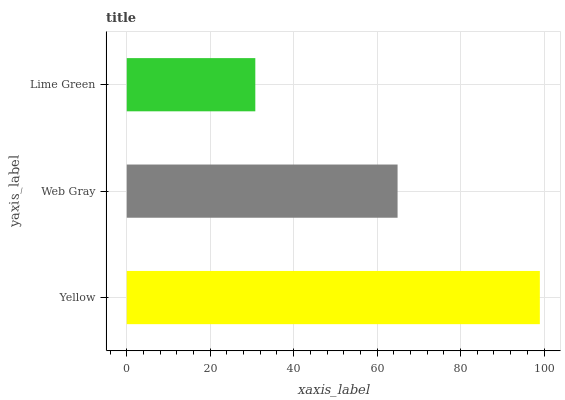Is Lime Green the minimum?
Answer yes or no. Yes. Is Yellow the maximum?
Answer yes or no. Yes. Is Web Gray the minimum?
Answer yes or no. No. Is Web Gray the maximum?
Answer yes or no. No. Is Yellow greater than Web Gray?
Answer yes or no. Yes. Is Web Gray less than Yellow?
Answer yes or no. Yes. Is Web Gray greater than Yellow?
Answer yes or no. No. Is Yellow less than Web Gray?
Answer yes or no. No. Is Web Gray the high median?
Answer yes or no. Yes. Is Web Gray the low median?
Answer yes or no. Yes. Is Yellow the high median?
Answer yes or no. No. Is Lime Green the low median?
Answer yes or no. No. 